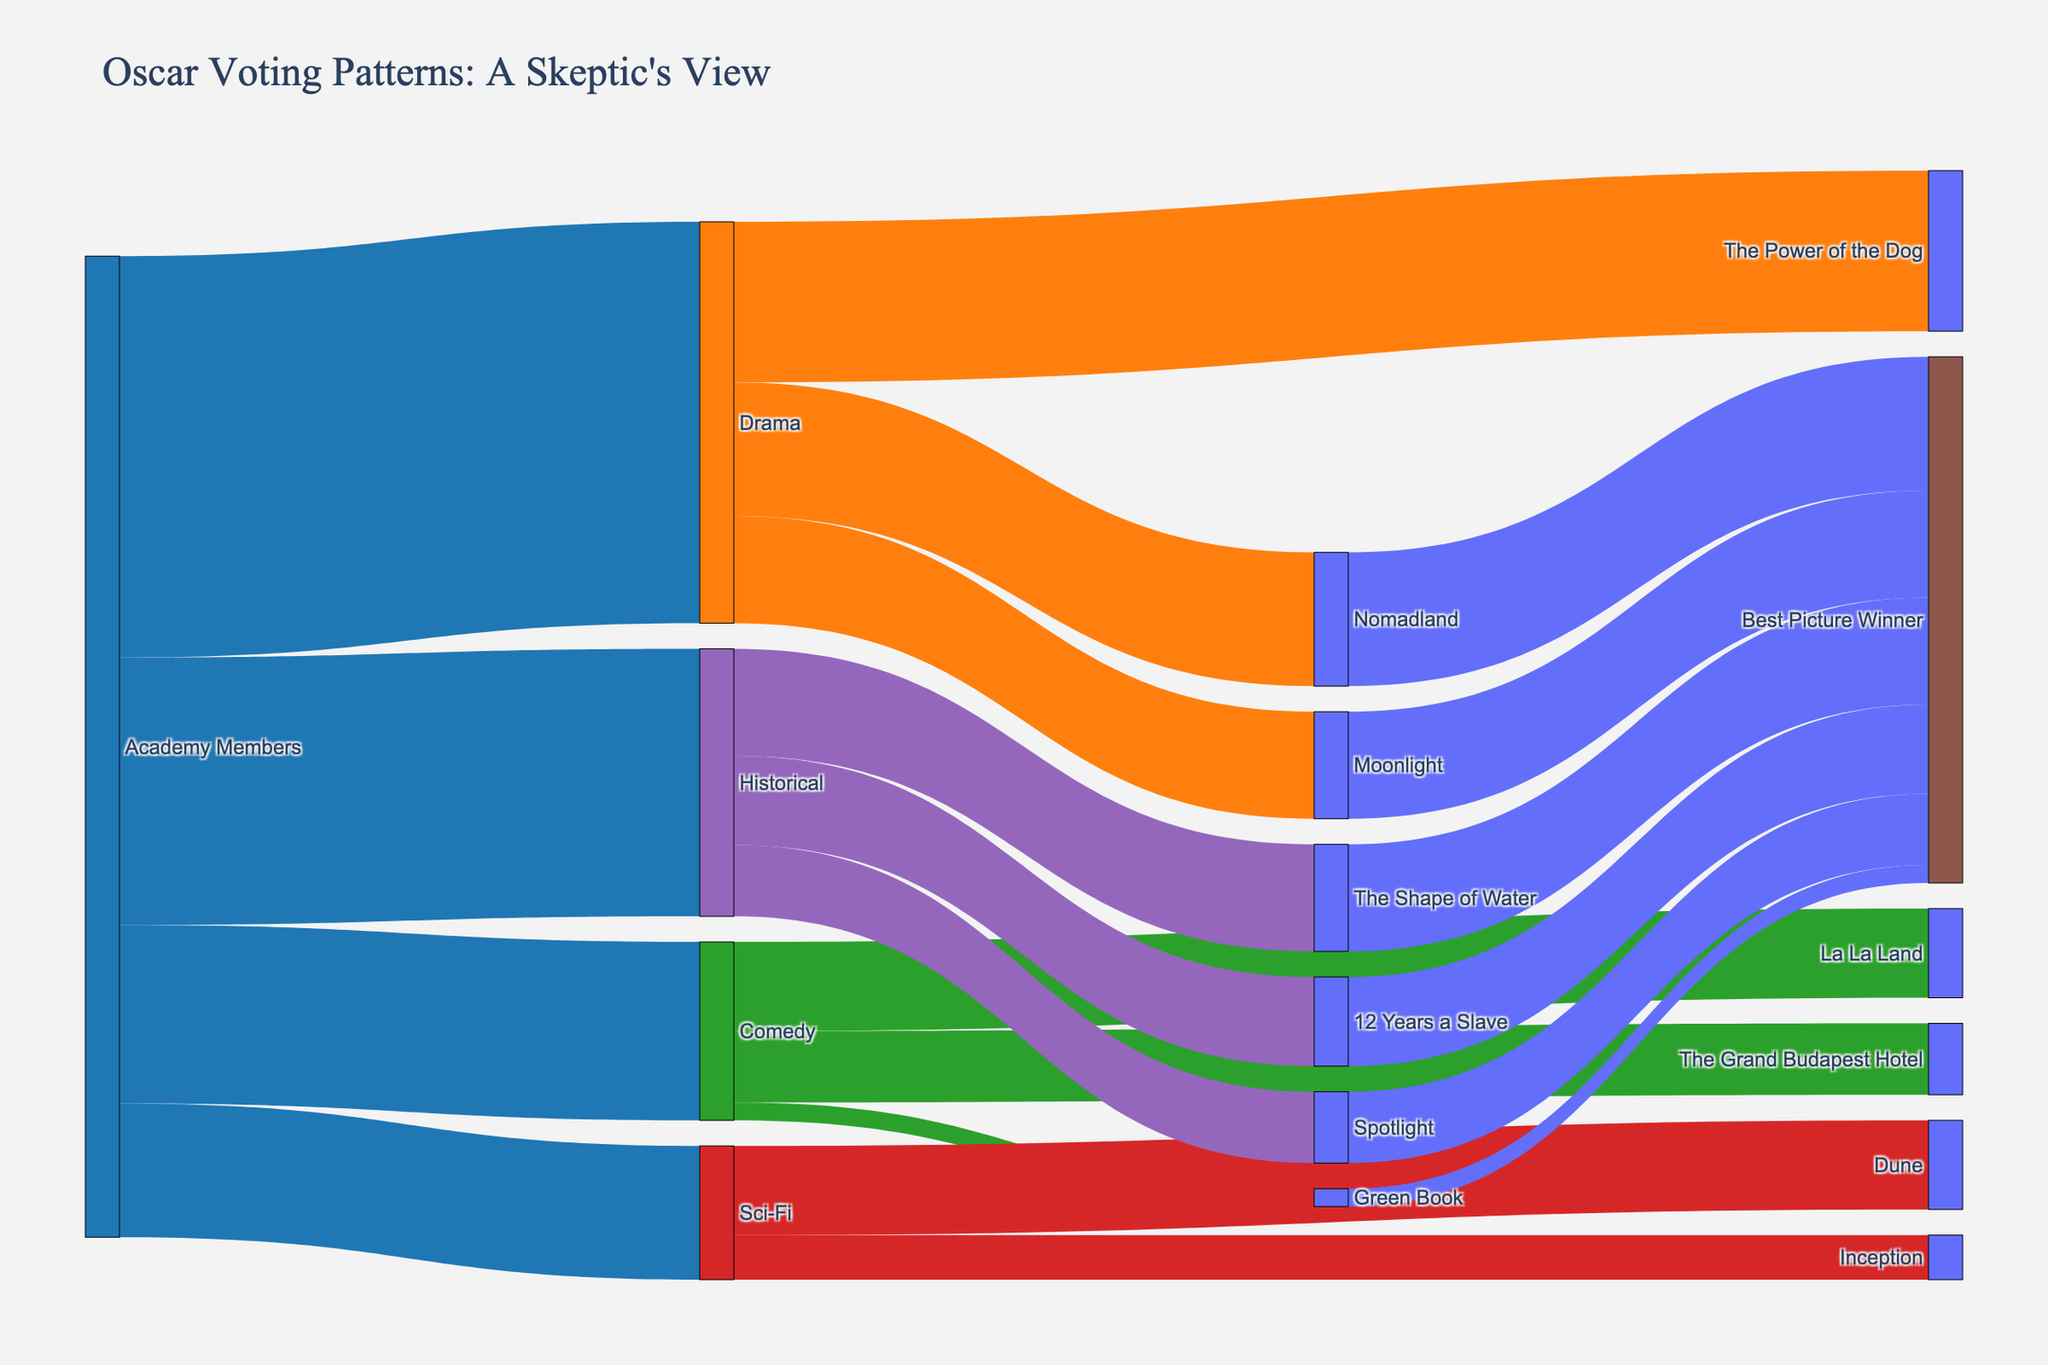What's the largest category of votes among Drama, Comedy, Sci-Fi, and Historical? Look at the connections coming out from "Academy Members" and compare the values. Drama has 450, Comedy has 200, Sci-Fi has 150, and Historical has 300.
Answer: Drama Which Drama nominee received the fewest votes? Look at the connections coming out from "Drama" and compare the values. "Moonlight" received 120 votes, the lowest among Drama nominees.
Answer: Moonlight How many votes did "The Shape of Water" receive in total, including its win for Best Picture? There are 120 votes going from "Historical" to "The Shape of Water" and another 120 votes from "The Shape of Water" to "Best Picture Winner." Summing these gives 240.
Answer: 240 Which category has the highest percentage of its votes ending up with a Best Picture Winner? Calculate the percentage for each category. Drama: (150+120)/450 = 60%, Comedy: (20/200) = 10%, Sci-Fi: 0/150 = 0%, Historical: (120+100+80)/300 = 100%. Historical has the highest percentage.
Answer: Historical Which movie received the least number of votes before winning Best Picture? Look for connections to "Best Picture Winner" and compare values. "Spotlight" has 80 votes, the least before winning.
Answer: Spotlight How many Drama movies have won Best Picture? Count the connections from Drama movies to "Best Picture Winner" with values greater than 0. "Nomadland" and "Moonlight" each have values going to "Best Picture Winner."
Answer: 2 Between Comedy and Sci-Fi, which category had more votes making it to Best Picture Winners? Sum the connections from Comedy and Sci-Fi to Best Picture Winner. Comedy: 20; Sci-Fi: 0. Comedy has more votes making it to Best Picture Winners.
Answer: Comedy What's the total number of votes for the Best Picture Winner over the past decade? Sum all links going to "Best Picture Winner". This includes 150 + 120 (Nomadland) + 100 (12 Years a Slave) + 120 (The Shape of Water) + 20 (Green Book) + 80 (Spotlight), totaling 590 votes.
Answer: 590 How many nominees from the Historical category won Best Picture? Look at connections from Historical movies to "Best Picture Winner" and count those with values greater than 0: "The Shape of Water," "12 Years a Slave," and "Spotlight."
Answer: 3 